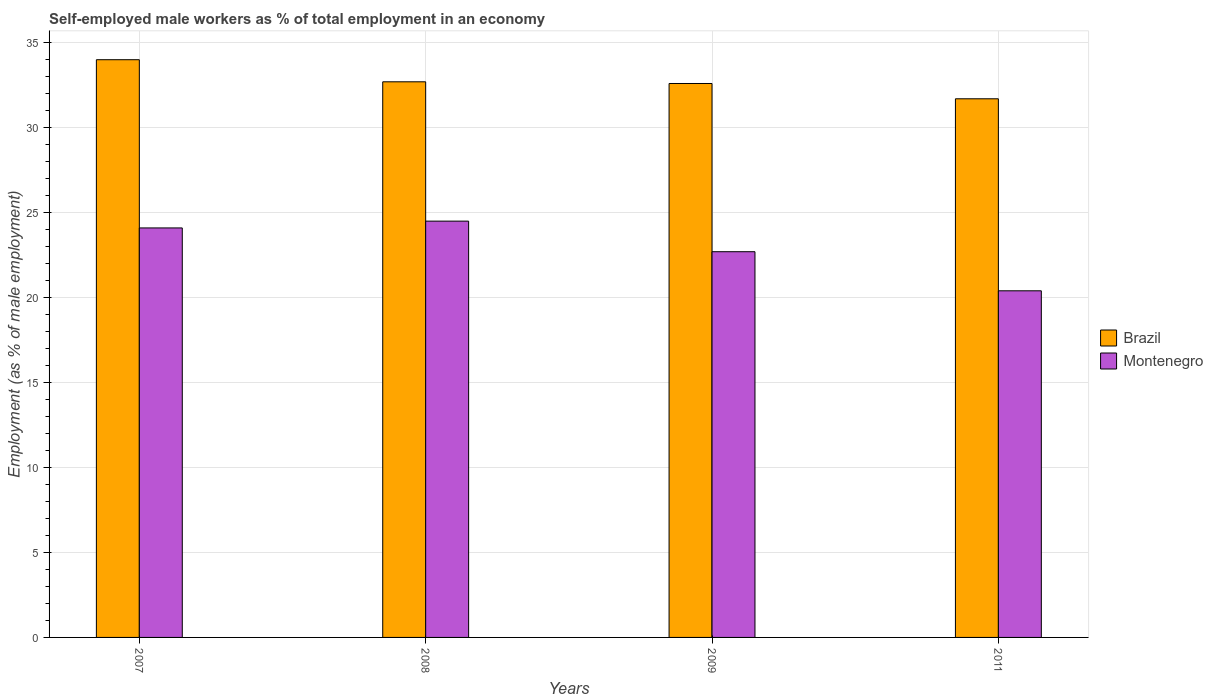Are the number of bars on each tick of the X-axis equal?
Your answer should be compact. Yes. How many bars are there on the 4th tick from the right?
Ensure brevity in your answer.  2. What is the percentage of self-employed male workers in Brazil in 2009?
Provide a short and direct response. 32.6. Across all years, what is the minimum percentage of self-employed male workers in Brazil?
Your response must be concise. 31.7. In which year was the percentage of self-employed male workers in Brazil maximum?
Your answer should be compact. 2007. In which year was the percentage of self-employed male workers in Brazil minimum?
Your answer should be very brief. 2011. What is the total percentage of self-employed male workers in Montenegro in the graph?
Give a very brief answer. 91.7. What is the difference between the percentage of self-employed male workers in Brazil in 2007 and that in 2011?
Your answer should be very brief. 2.3. What is the difference between the percentage of self-employed male workers in Brazil in 2011 and the percentage of self-employed male workers in Montenegro in 2008?
Your answer should be compact. 7.2. What is the average percentage of self-employed male workers in Montenegro per year?
Provide a short and direct response. 22.93. In the year 2008, what is the difference between the percentage of self-employed male workers in Montenegro and percentage of self-employed male workers in Brazil?
Ensure brevity in your answer.  -8.2. What is the ratio of the percentage of self-employed male workers in Brazil in 2007 to that in 2008?
Provide a short and direct response. 1.04. Is the percentage of self-employed male workers in Brazil in 2007 less than that in 2008?
Offer a terse response. No. Is the difference between the percentage of self-employed male workers in Montenegro in 2007 and 2009 greater than the difference between the percentage of self-employed male workers in Brazil in 2007 and 2009?
Make the answer very short. No. What is the difference between the highest and the second highest percentage of self-employed male workers in Montenegro?
Ensure brevity in your answer.  0.4. What is the difference between the highest and the lowest percentage of self-employed male workers in Brazil?
Your response must be concise. 2.3. What does the 1st bar from the left in 2008 represents?
Your response must be concise. Brazil. Are the values on the major ticks of Y-axis written in scientific E-notation?
Keep it short and to the point. No. Does the graph contain any zero values?
Your answer should be compact. No. Does the graph contain grids?
Offer a terse response. Yes. Where does the legend appear in the graph?
Ensure brevity in your answer.  Center right. How are the legend labels stacked?
Ensure brevity in your answer.  Vertical. What is the title of the graph?
Ensure brevity in your answer.  Self-employed male workers as % of total employment in an economy. What is the label or title of the X-axis?
Your response must be concise. Years. What is the label or title of the Y-axis?
Your answer should be very brief. Employment (as % of male employment). What is the Employment (as % of male employment) of Brazil in 2007?
Provide a succinct answer. 34. What is the Employment (as % of male employment) of Montenegro in 2007?
Your response must be concise. 24.1. What is the Employment (as % of male employment) in Brazil in 2008?
Offer a very short reply. 32.7. What is the Employment (as % of male employment) of Montenegro in 2008?
Give a very brief answer. 24.5. What is the Employment (as % of male employment) in Brazil in 2009?
Provide a succinct answer. 32.6. What is the Employment (as % of male employment) of Montenegro in 2009?
Your answer should be very brief. 22.7. What is the Employment (as % of male employment) in Brazil in 2011?
Make the answer very short. 31.7. What is the Employment (as % of male employment) in Montenegro in 2011?
Your answer should be very brief. 20.4. Across all years, what is the maximum Employment (as % of male employment) in Montenegro?
Your answer should be very brief. 24.5. Across all years, what is the minimum Employment (as % of male employment) in Brazil?
Your response must be concise. 31.7. Across all years, what is the minimum Employment (as % of male employment) in Montenegro?
Your answer should be very brief. 20.4. What is the total Employment (as % of male employment) in Brazil in the graph?
Offer a terse response. 131. What is the total Employment (as % of male employment) of Montenegro in the graph?
Your answer should be very brief. 91.7. What is the difference between the Employment (as % of male employment) of Brazil in 2007 and that in 2008?
Ensure brevity in your answer.  1.3. What is the difference between the Employment (as % of male employment) in Montenegro in 2007 and that in 2008?
Make the answer very short. -0.4. What is the difference between the Employment (as % of male employment) in Brazil in 2007 and that in 2009?
Provide a succinct answer. 1.4. What is the difference between the Employment (as % of male employment) of Montenegro in 2007 and that in 2011?
Make the answer very short. 3.7. What is the difference between the Employment (as % of male employment) in Montenegro in 2008 and that in 2009?
Offer a terse response. 1.8. What is the difference between the Employment (as % of male employment) in Brazil in 2007 and the Employment (as % of male employment) in Montenegro in 2009?
Your answer should be compact. 11.3. What is the difference between the Employment (as % of male employment) of Brazil in 2007 and the Employment (as % of male employment) of Montenegro in 2011?
Your answer should be very brief. 13.6. What is the difference between the Employment (as % of male employment) in Brazil in 2008 and the Employment (as % of male employment) in Montenegro in 2009?
Make the answer very short. 10. What is the average Employment (as % of male employment) of Brazil per year?
Offer a terse response. 32.75. What is the average Employment (as % of male employment) in Montenegro per year?
Keep it short and to the point. 22.93. In the year 2009, what is the difference between the Employment (as % of male employment) in Brazil and Employment (as % of male employment) in Montenegro?
Your answer should be compact. 9.9. In the year 2011, what is the difference between the Employment (as % of male employment) of Brazil and Employment (as % of male employment) of Montenegro?
Your answer should be compact. 11.3. What is the ratio of the Employment (as % of male employment) in Brazil in 2007 to that in 2008?
Give a very brief answer. 1.04. What is the ratio of the Employment (as % of male employment) in Montenegro in 2007 to that in 2008?
Provide a succinct answer. 0.98. What is the ratio of the Employment (as % of male employment) of Brazil in 2007 to that in 2009?
Offer a very short reply. 1.04. What is the ratio of the Employment (as % of male employment) in Montenegro in 2007 to that in 2009?
Your answer should be very brief. 1.06. What is the ratio of the Employment (as % of male employment) in Brazil in 2007 to that in 2011?
Provide a succinct answer. 1.07. What is the ratio of the Employment (as % of male employment) of Montenegro in 2007 to that in 2011?
Offer a very short reply. 1.18. What is the ratio of the Employment (as % of male employment) of Brazil in 2008 to that in 2009?
Your answer should be very brief. 1. What is the ratio of the Employment (as % of male employment) in Montenegro in 2008 to that in 2009?
Give a very brief answer. 1.08. What is the ratio of the Employment (as % of male employment) in Brazil in 2008 to that in 2011?
Ensure brevity in your answer.  1.03. What is the ratio of the Employment (as % of male employment) in Montenegro in 2008 to that in 2011?
Keep it short and to the point. 1.2. What is the ratio of the Employment (as % of male employment) in Brazil in 2009 to that in 2011?
Ensure brevity in your answer.  1.03. What is the ratio of the Employment (as % of male employment) in Montenegro in 2009 to that in 2011?
Give a very brief answer. 1.11. What is the difference between the highest and the second highest Employment (as % of male employment) of Montenegro?
Your answer should be compact. 0.4. 